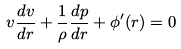<formula> <loc_0><loc_0><loc_500><loc_500>v \frac { d v } { d r } + \frac { 1 } { \rho } \frac { d p } { d r } + \phi ^ { \prime } ( r ) = 0</formula> 